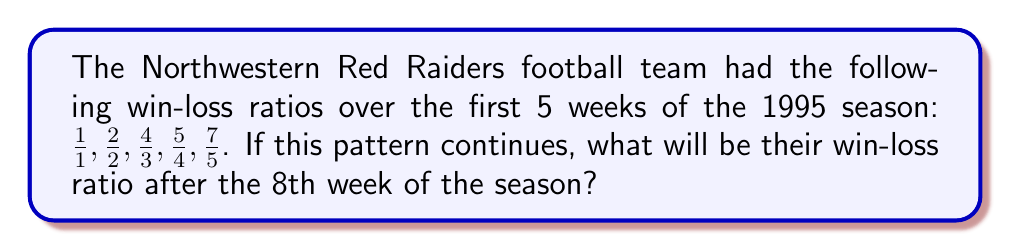Provide a solution to this math problem. Let's analyze the pattern in the given sequence:

1) First, we need to identify the pattern in the numerator and denominator separately:

   Numerators: 1, 2, 4, 5, 7
   Denominators: 1, 2, 3, 4, 5

2) We can see that the denominator is simply the week number.

3) For the numerator, let's calculate the differences:
   1 to 2: +1
   2 to 4: +2
   4 to 5: +1
   5 to 7: +2

   We can see that it alternates between adding 1 and adding 2.

4) So, to continue the pattern for weeks 6, 7, and 8:

   Week 6: $\frac{7+1}{6} = \frac{8}{6}$
   Week 7: $\frac{8+2}{7} = \frac{10}{7}$
   Week 8: $\frac{10+1}{8} = \frac{11}{8}$

5) Therefore, after the 8th week, the win-loss ratio will be $\frac{11}{8}$.
Answer: $\frac{11}{8}$ 